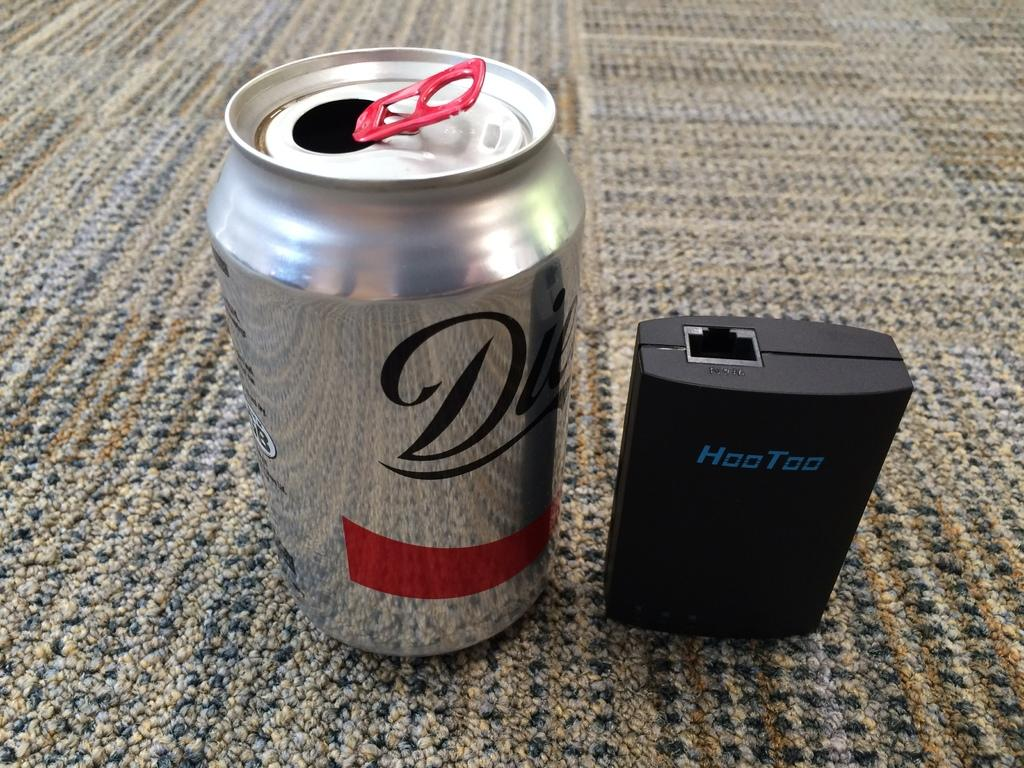<image>
Share a concise interpretation of the image provided. A Hoo Too item sits on the floor next to a diet soda can. 